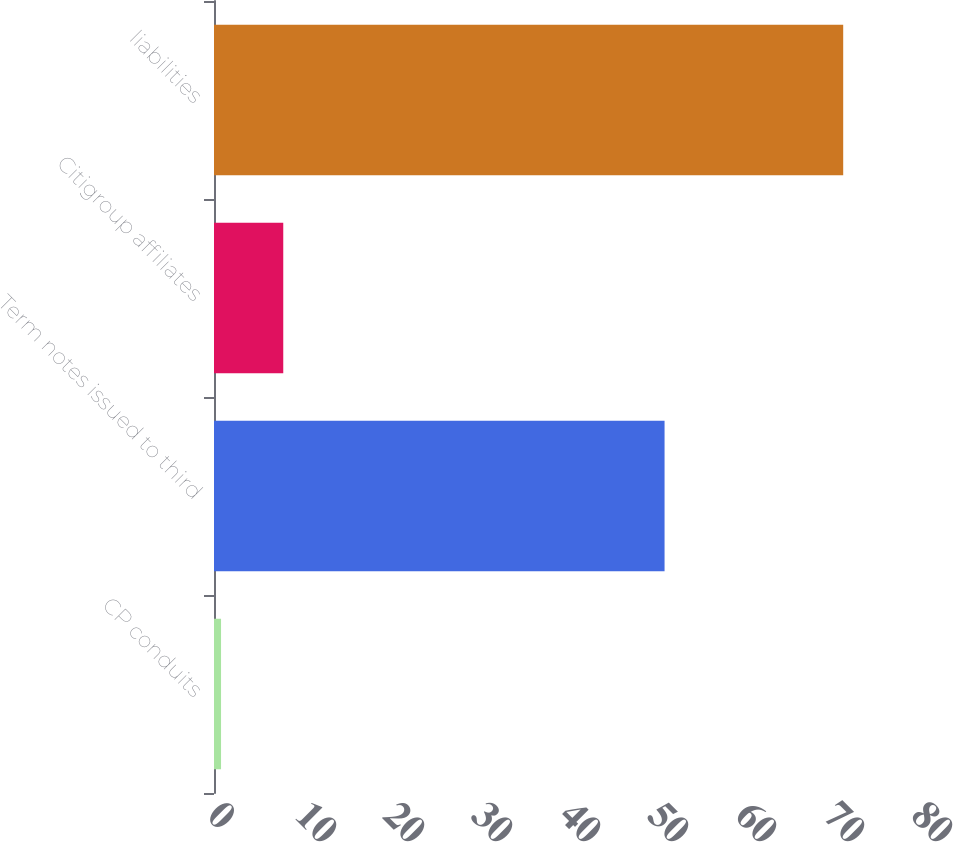<chart> <loc_0><loc_0><loc_500><loc_500><bar_chart><fcel>CP conduits<fcel>Term notes issued to third<fcel>Citigroup affiliates<fcel>liabilities<nl><fcel>0.8<fcel>51.2<fcel>7.87<fcel>71.5<nl></chart> 